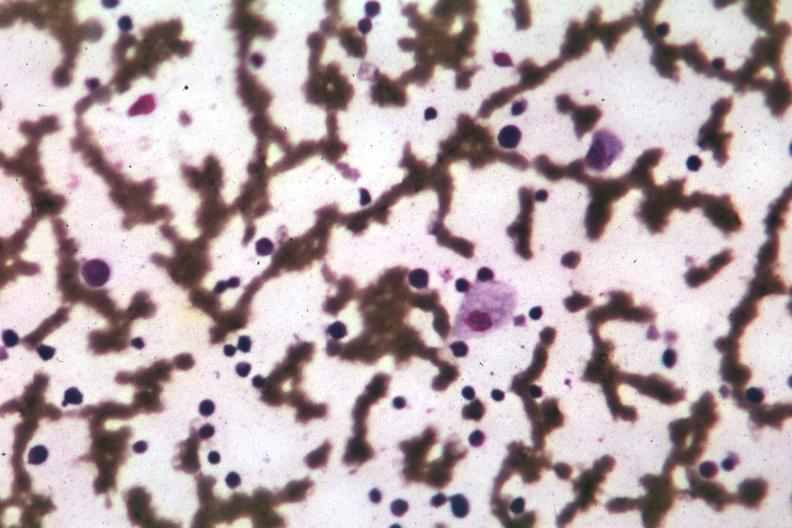s hours seen seen?
Answer the question using a single word or phrase. No 